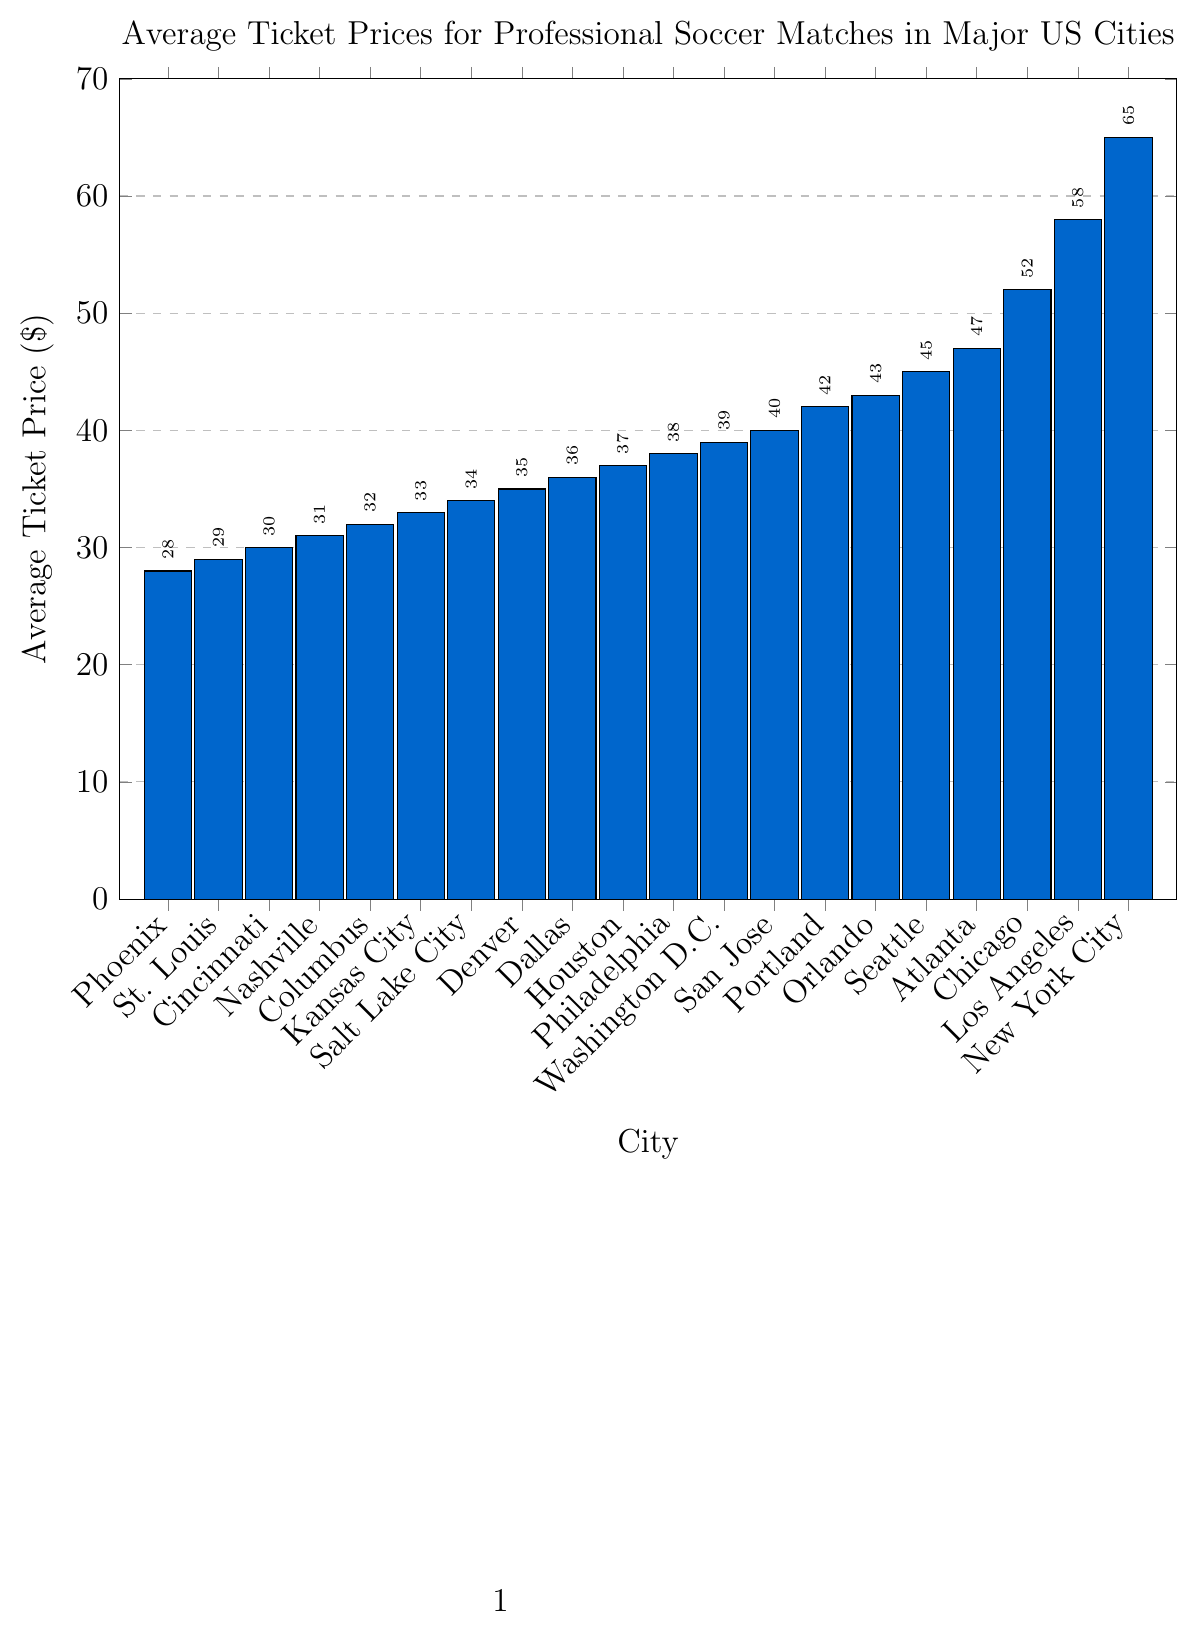What's the average ticket price for matches in the four most expensive cities? To find the average ticket price for the four most expensive cities, add the prices for New York City ($65), Los Angeles ($58), Chicago ($52), and Atlanta ($47), then divide by four. So, (65 + 58 + 52 + 47) / 4 = 222 / 4 = 55.5
Answer: 55.5 Which city has the lowest average ticket price and what is it? The city with the lowest bar on the plot has the lowest average ticket price. From the chart, Phoenix has the lowest average ticket price, which is $28.
Answer: Phoenix, 28 How much more expensive is the average ticket price in Los Angeles compared to Phoenix? Subtract the average ticket price of Phoenix ($28) from that of Los Angeles ($58): 58 - 28 = 30.
Answer: 30 What is the combined ticket price of the three least expensive cities? Add the ticket prices for Phoenix ($28), St. Louis ($29), and Cincinnati ($30): 28 + 29 + 30 = 87.
Answer: 87 Which cities have ticket prices between $35 and $45? From the chart, the cities with ticket prices in this range are Denver ($35), Dallas ($36), Houston ($37), Philadelphia ($38), Washington D.C. ($39), San Jose ($40), and Orlando ($43).
Answer: Denver, Dallas, Houston, Philadelphia, Washington D.C., San Jose, Orlando What is the median ticket price among all the listed cities? To find the median, list all the ticket prices in ascending order and find the middle value. The prices in ascending order are: 28, 29, 30, 31, 32, 33, 34, 35, 36, 37, 38, 39, 40, 42, 43, 45, 47, 52, 58, 65. There are 20 values, so the median is the average of the 10th and 11th values: (38 + 39) / 2 = 38.5.
Answer: 38.5 How does the ticket price in Seattle compare to that in Orlando? From the chart, the bar for Seattle ($45) is slightly higher than the bar for Orlando ($43). Therefore, Seattle's ticket price is $2 more than Orlando's.
Answer: 2 